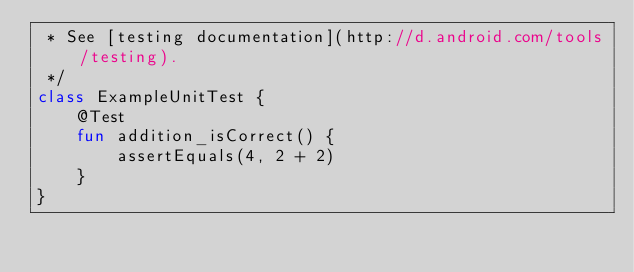Convert code to text. <code><loc_0><loc_0><loc_500><loc_500><_Kotlin_> * See [testing documentation](http://d.android.com/tools/testing).
 */
class ExampleUnitTest {
    @Test
    fun addition_isCorrect() {
        assertEquals(4, 2 + 2)
    }
}
</code> 